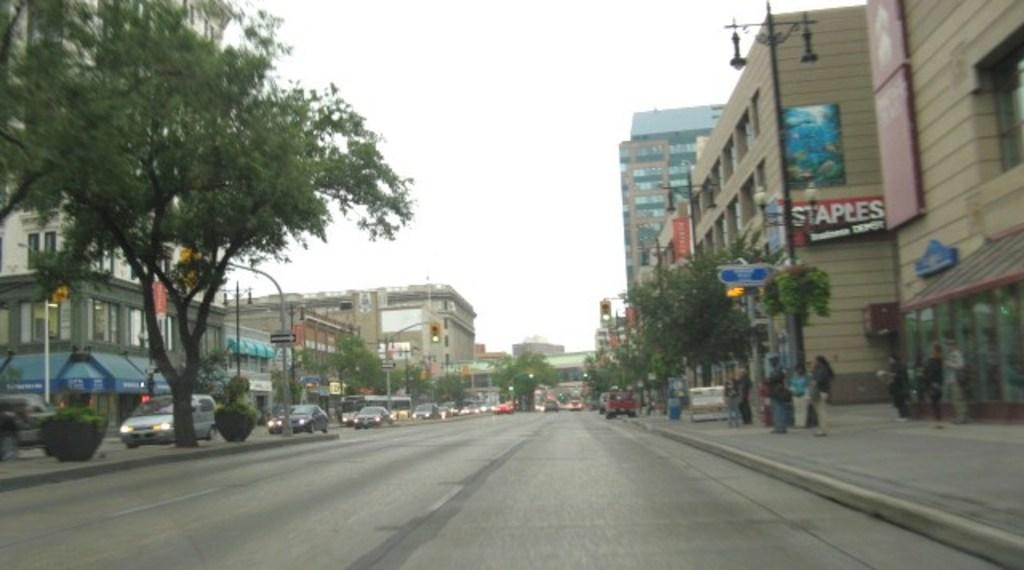What can be seen on the road in the image? There are vehicles on the road in the image. What type of natural elements are present in the image? There are plants in the image. What structures can be seen in the image? There are poles, lights, boards, and buildings in the image. Who or what else is present in the image? There are people in the image. What is visible in the background of the image? The sky is visible in the background of the image. What is the name of the person who is angry in the image? There is no person shown expressing anger in the image. What is the opinion of the person standing next to the building in the image? There is no indication of anyone's opinion in the image. 